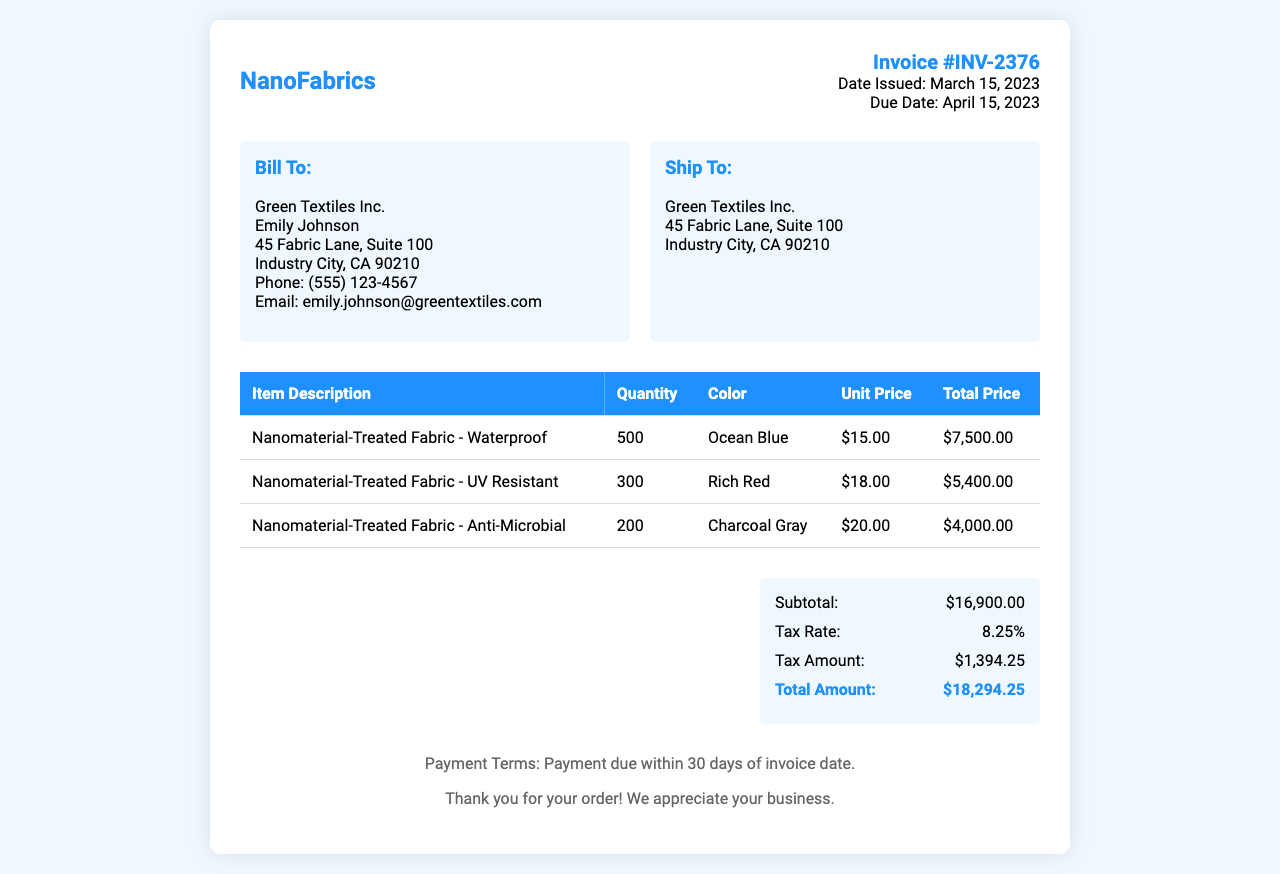What is the invoice number? The invoice number is stated prominently in the document for identification purposes.
Answer: INV-2376 What is the date issued? The date issued is mentioned in the document to indicate when the invoice was created.
Answer: March 15, 2023 Who is the billing contact? The billing contact's name is provided to ensure proper communication related to the invoice.
Answer: Emily Johnson What is the quantity of the Waterproof fabric? The quantity of the Waterproof fabric is listed in the table detailing the fabrics ordered.
Answer: 500 What is the total amount due? The total amount due is the final figure calculated after tax and subtotal listed in the invoice.
Answer: $18,294.25 What is the tax rate applied? The tax rate is stated to show what percentage of the subtotal was added as tax.
Answer: 8.25% How many different types of fabrics are listed? The number of different types of fabrics can be counted from the items in the invoice.
Answer: 3 What is the color of the Anti-Microbial fabric? The color of the Anti-Microbial fabric is specified in the fabric description section of the invoice.
Answer: Charcoal Gray What payment terms are specified? The payment terms indicate when the payment is expected in relation to the invoice date.
Answer: Payment due within 30 days of invoice date 